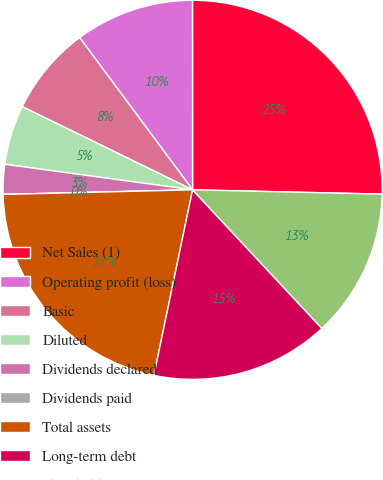<chart> <loc_0><loc_0><loc_500><loc_500><pie_chart><fcel>Net Sales (1)<fcel>Operating profit (loss)<fcel>Basic<fcel>Diluted<fcel>Dividends declared<fcel>Dividends paid<fcel>Total assets<fcel>Long-term debt<fcel>Shareholders' equity<nl><fcel>25.37%<fcel>10.15%<fcel>7.61%<fcel>5.08%<fcel>2.54%<fcel>0.0%<fcel>21.34%<fcel>15.22%<fcel>12.69%<nl></chart> 